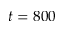Convert formula to latex. <formula><loc_0><loc_0><loc_500><loc_500>t = 8 0 0</formula> 